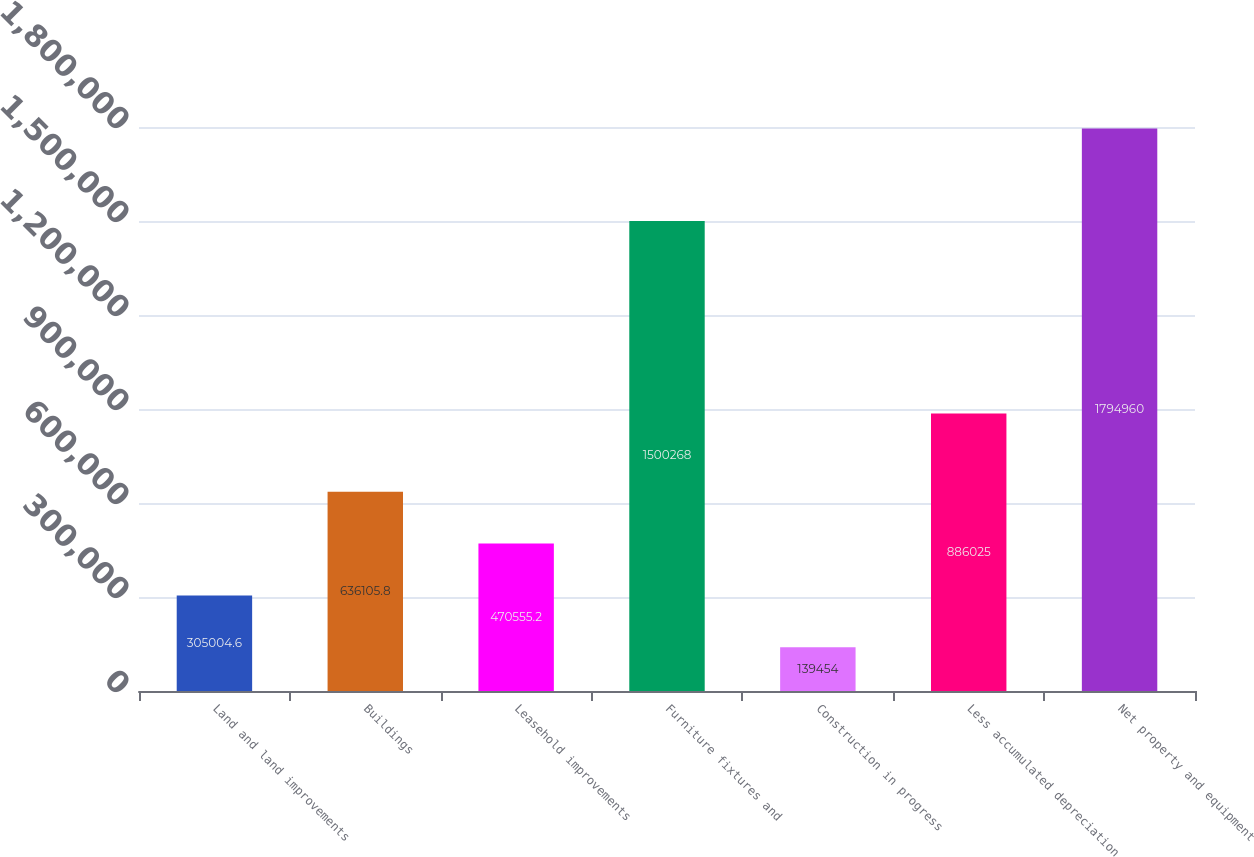Convert chart. <chart><loc_0><loc_0><loc_500><loc_500><bar_chart><fcel>Land and land improvements<fcel>Buildings<fcel>Leasehold improvements<fcel>Furniture fixtures and<fcel>Construction in progress<fcel>Less accumulated depreciation<fcel>Net property and equipment<nl><fcel>305005<fcel>636106<fcel>470555<fcel>1.50027e+06<fcel>139454<fcel>886025<fcel>1.79496e+06<nl></chart> 